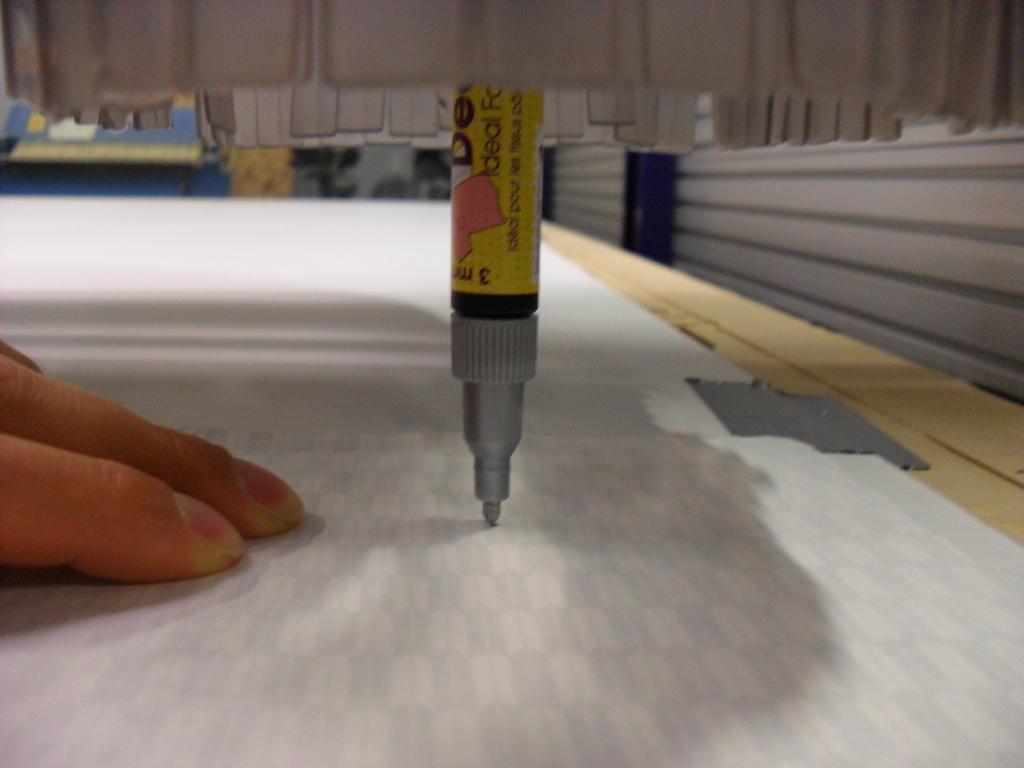What number is upside?
Provide a succinct answer. 3. 